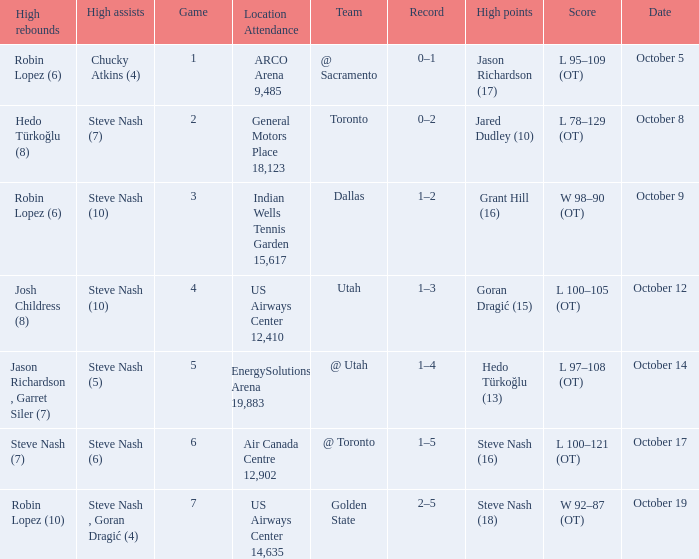How many games had Robin Lopez (10) for the most rebounds? 1.0. 